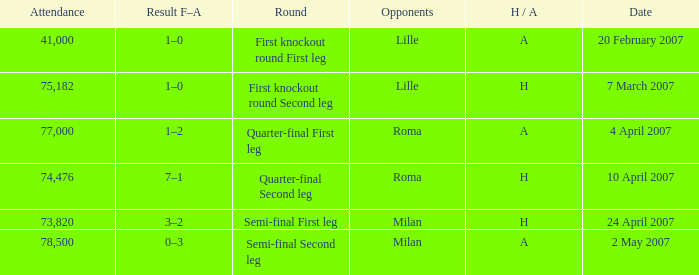Which date has roma as opponent and a H/A of A? 4 April 2007. 